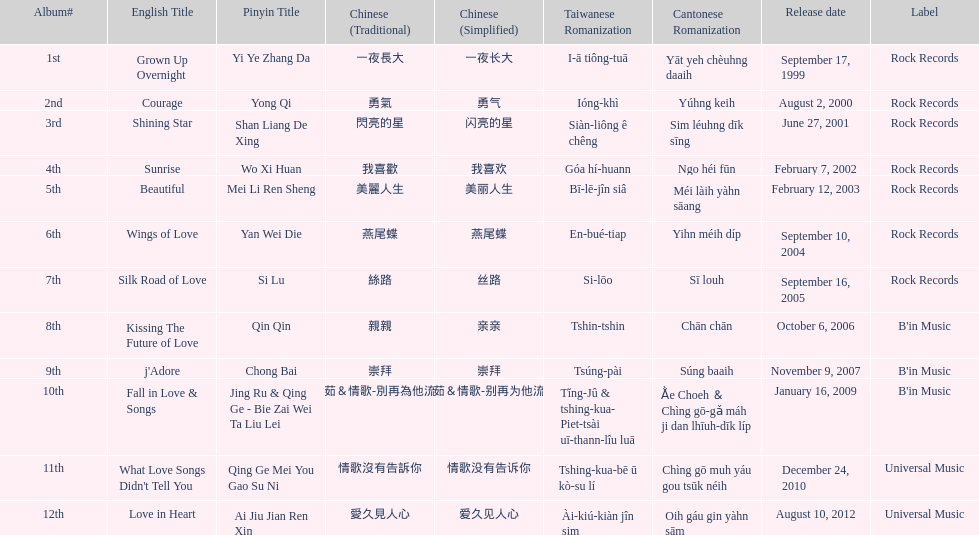What label was she working with before universal music? B'in Music. 